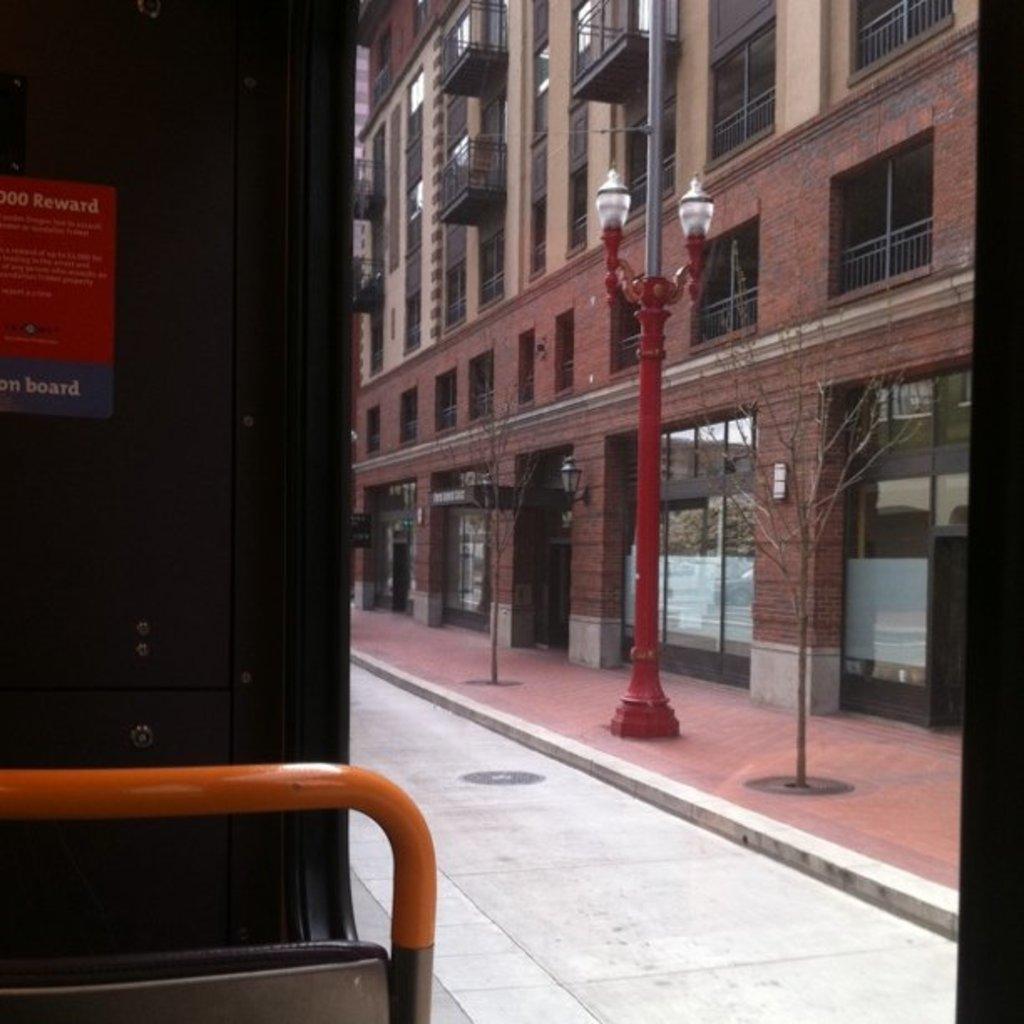Could you give a brief overview of what you see in this image? This picture is clicked outside. On the left we can see the metal rod and a poster attached to the black color object and we can see the text on the poster. On the right we can see the lamps attached to the pole and we can see the dry stems and branches of the trees and we can see the building, windows and deck rails of the building and we can see the wall mounted lamps. 